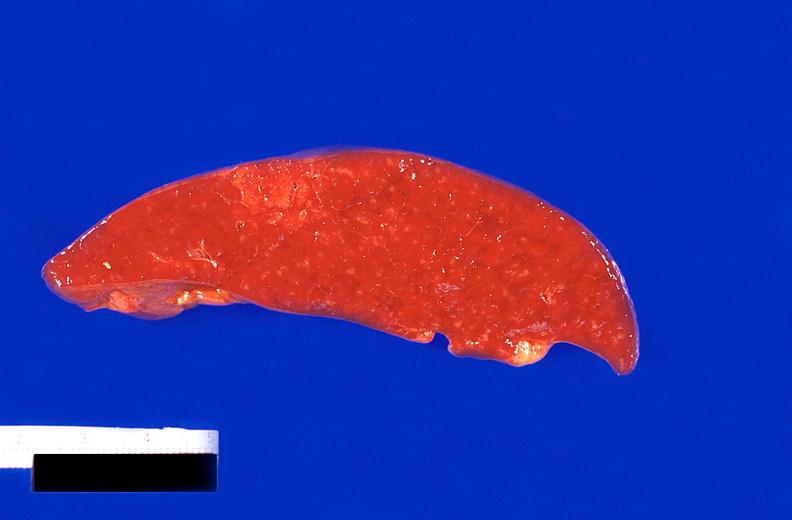s bone, clivus present?
Answer the question using a single word or phrase. No 